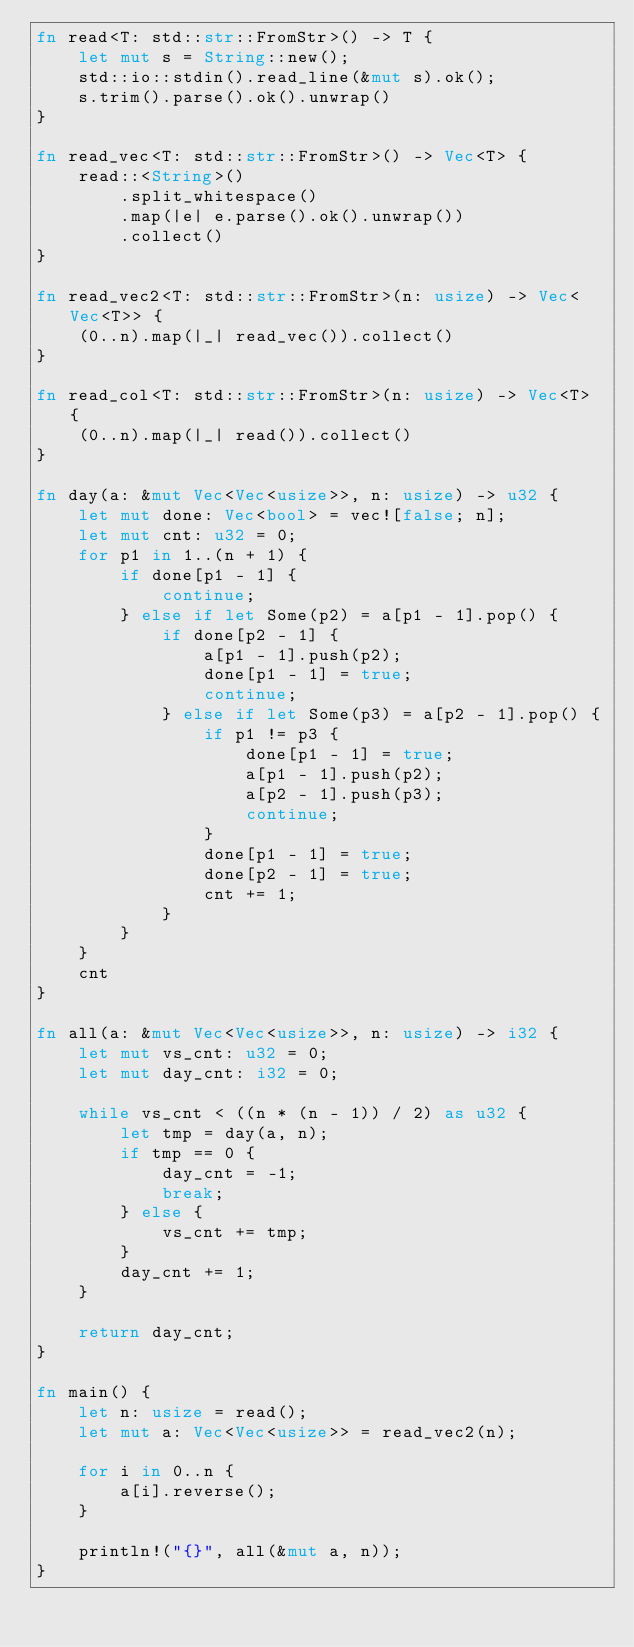<code> <loc_0><loc_0><loc_500><loc_500><_Rust_>fn read<T: std::str::FromStr>() -> T {
    let mut s = String::new();
    std::io::stdin().read_line(&mut s).ok();
    s.trim().parse().ok().unwrap()
}

fn read_vec<T: std::str::FromStr>() -> Vec<T> {
    read::<String>()
        .split_whitespace()
        .map(|e| e.parse().ok().unwrap())
        .collect()
}

fn read_vec2<T: std::str::FromStr>(n: usize) -> Vec<Vec<T>> {
    (0..n).map(|_| read_vec()).collect()
}

fn read_col<T: std::str::FromStr>(n: usize) -> Vec<T> {
    (0..n).map(|_| read()).collect()
}

fn day(a: &mut Vec<Vec<usize>>, n: usize) -> u32 {
    let mut done: Vec<bool> = vec![false; n];
    let mut cnt: u32 = 0;
    for p1 in 1..(n + 1) {
        if done[p1 - 1] {
            continue;
        } else if let Some(p2) = a[p1 - 1].pop() {
            if done[p2 - 1] {
                a[p1 - 1].push(p2);
                done[p1 - 1] = true;
                continue;
            } else if let Some(p3) = a[p2 - 1].pop() {
                if p1 != p3 {
                    done[p1 - 1] = true;
                    a[p1 - 1].push(p2);
                    a[p2 - 1].push(p3);
                    continue;
                }
                done[p1 - 1] = true;
                done[p2 - 1] = true;
                cnt += 1;
            }
        }
    }
    cnt
}

fn all(a: &mut Vec<Vec<usize>>, n: usize) -> i32 {
    let mut vs_cnt: u32 = 0;
    let mut day_cnt: i32 = 0;

    while vs_cnt < ((n * (n - 1)) / 2) as u32 {
        let tmp = day(a, n);
        if tmp == 0 {
            day_cnt = -1;
            break;
        } else {
            vs_cnt += tmp;
        }
        day_cnt += 1;
    }

    return day_cnt;
}

fn main() {
    let n: usize = read();
    let mut a: Vec<Vec<usize>> = read_vec2(n);

    for i in 0..n {
        a[i].reverse();
    }

    println!("{}", all(&mut a, n));
}
</code> 